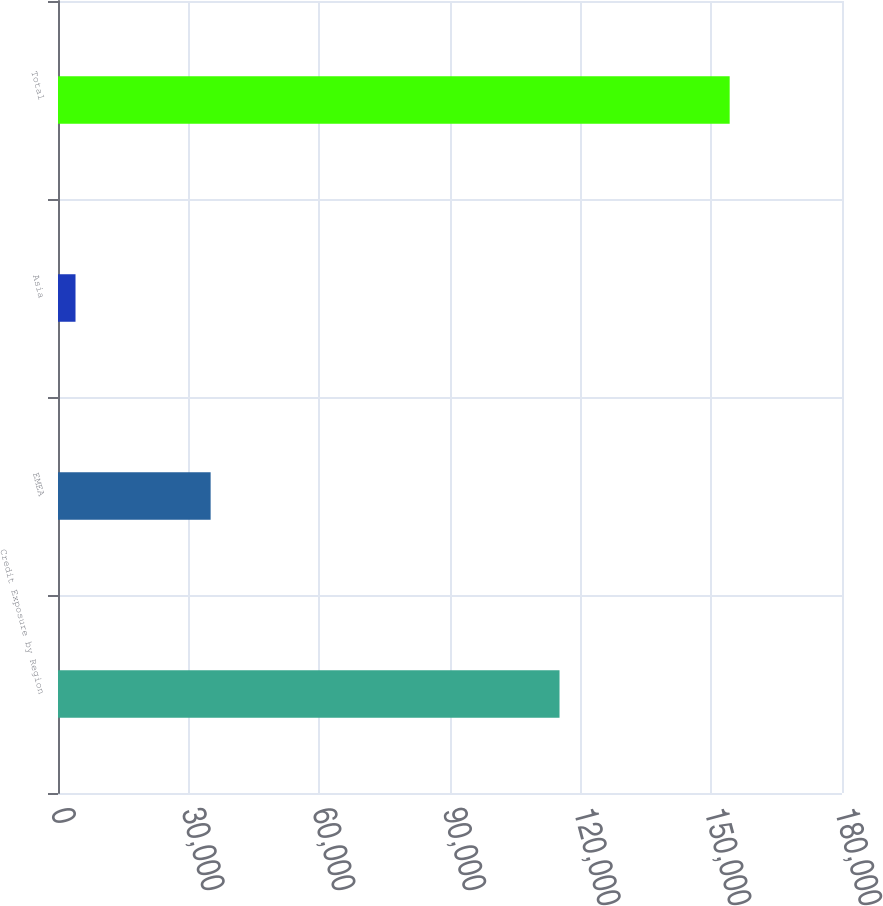Convert chart. <chart><loc_0><loc_0><loc_500><loc_500><bar_chart><fcel>Credit Exposure by Region<fcel>EMEA<fcel>Asia<fcel>Total<nl><fcel>115145<fcel>35044<fcel>4021<fcel>154210<nl></chart> 